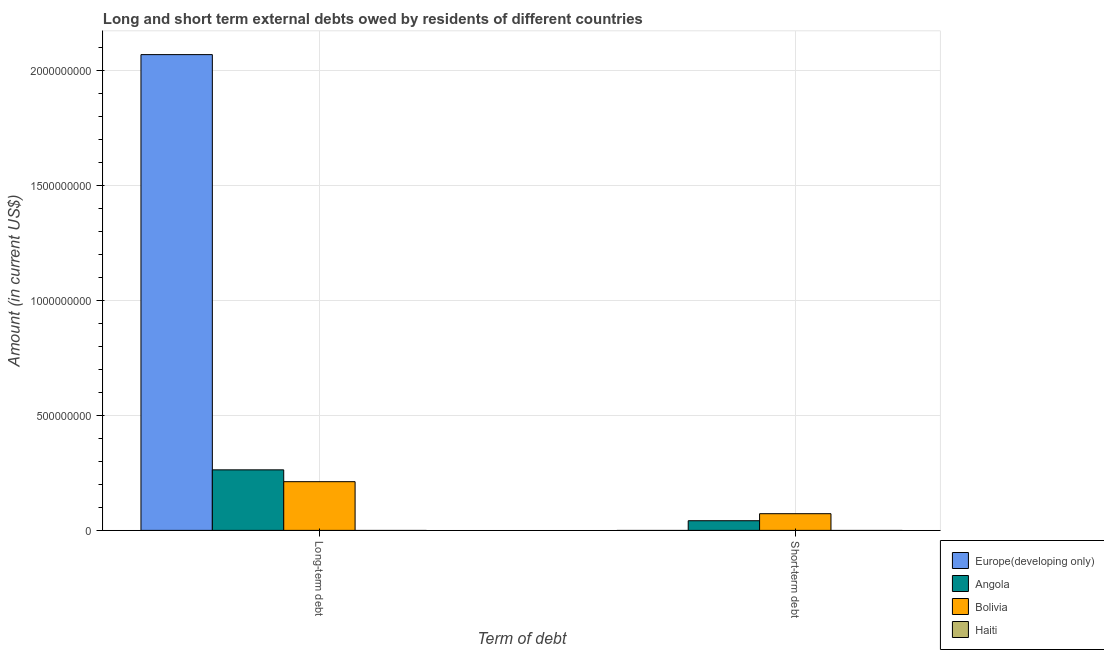How many groups of bars are there?
Offer a terse response. 2. Are the number of bars per tick equal to the number of legend labels?
Give a very brief answer. No. Are the number of bars on each tick of the X-axis equal?
Offer a terse response. No. How many bars are there on the 2nd tick from the left?
Your response must be concise. 2. What is the label of the 2nd group of bars from the left?
Ensure brevity in your answer.  Short-term debt. What is the long-term debts owed by residents in Bolivia?
Provide a short and direct response. 2.12e+08. Across all countries, what is the maximum short-term debts owed by residents?
Offer a very short reply. 7.26e+07. Across all countries, what is the minimum long-term debts owed by residents?
Provide a short and direct response. 0. What is the total short-term debts owed by residents in the graph?
Provide a succinct answer. 1.15e+08. What is the difference between the long-term debts owed by residents in Angola and that in Bolivia?
Keep it short and to the point. 5.15e+07. What is the difference between the short-term debts owed by residents in Angola and the long-term debts owed by residents in Haiti?
Your response must be concise. 4.20e+07. What is the average short-term debts owed by residents per country?
Keep it short and to the point. 2.86e+07. What is the difference between the short-term debts owed by residents and long-term debts owed by residents in Bolivia?
Provide a succinct answer. -1.39e+08. In how many countries, is the short-term debts owed by residents greater than 1500000000 US$?
Offer a very short reply. 0. What is the ratio of the long-term debts owed by residents in Angola to that in Bolivia?
Your answer should be very brief. 1.24. Is the long-term debts owed by residents in Bolivia less than that in Europe(developing only)?
Your answer should be very brief. Yes. How many bars are there?
Your answer should be very brief. 5. What is the difference between two consecutive major ticks on the Y-axis?
Offer a terse response. 5.00e+08. Does the graph contain any zero values?
Give a very brief answer. Yes. What is the title of the graph?
Keep it short and to the point. Long and short term external debts owed by residents of different countries. Does "Bhutan" appear as one of the legend labels in the graph?
Make the answer very short. No. What is the label or title of the X-axis?
Provide a short and direct response. Term of debt. What is the label or title of the Y-axis?
Provide a succinct answer. Amount (in current US$). What is the Amount (in current US$) of Europe(developing only) in Long-term debt?
Ensure brevity in your answer.  2.07e+09. What is the Amount (in current US$) of Angola in Long-term debt?
Provide a short and direct response. 2.63e+08. What is the Amount (in current US$) of Bolivia in Long-term debt?
Keep it short and to the point. 2.12e+08. What is the Amount (in current US$) of Haiti in Long-term debt?
Offer a very short reply. 0. What is the Amount (in current US$) in Angola in Short-term debt?
Provide a succinct answer. 4.20e+07. What is the Amount (in current US$) of Bolivia in Short-term debt?
Offer a terse response. 7.26e+07. Across all Term of debt, what is the maximum Amount (in current US$) in Europe(developing only)?
Provide a succinct answer. 2.07e+09. Across all Term of debt, what is the maximum Amount (in current US$) of Angola?
Your answer should be compact. 2.63e+08. Across all Term of debt, what is the maximum Amount (in current US$) of Bolivia?
Offer a very short reply. 2.12e+08. Across all Term of debt, what is the minimum Amount (in current US$) in Angola?
Your answer should be compact. 4.20e+07. Across all Term of debt, what is the minimum Amount (in current US$) in Bolivia?
Offer a terse response. 7.26e+07. What is the total Amount (in current US$) of Europe(developing only) in the graph?
Your response must be concise. 2.07e+09. What is the total Amount (in current US$) in Angola in the graph?
Ensure brevity in your answer.  3.05e+08. What is the total Amount (in current US$) in Bolivia in the graph?
Your answer should be very brief. 2.85e+08. What is the difference between the Amount (in current US$) of Angola in Long-term debt and that in Short-term debt?
Offer a very short reply. 2.21e+08. What is the difference between the Amount (in current US$) of Bolivia in Long-term debt and that in Short-term debt?
Offer a very short reply. 1.39e+08. What is the difference between the Amount (in current US$) of Europe(developing only) in Long-term debt and the Amount (in current US$) of Angola in Short-term debt?
Provide a short and direct response. 2.03e+09. What is the difference between the Amount (in current US$) in Europe(developing only) in Long-term debt and the Amount (in current US$) in Bolivia in Short-term debt?
Provide a short and direct response. 2.00e+09. What is the difference between the Amount (in current US$) in Angola in Long-term debt and the Amount (in current US$) in Bolivia in Short-term debt?
Provide a short and direct response. 1.91e+08. What is the average Amount (in current US$) of Europe(developing only) per Term of debt?
Offer a very short reply. 1.04e+09. What is the average Amount (in current US$) of Angola per Term of debt?
Ensure brevity in your answer.  1.53e+08. What is the average Amount (in current US$) of Bolivia per Term of debt?
Give a very brief answer. 1.42e+08. What is the difference between the Amount (in current US$) of Europe(developing only) and Amount (in current US$) of Angola in Long-term debt?
Keep it short and to the point. 1.81e+09. What is the difference between the Amount (in current US$) in Europe(developing only) and Amount (in current US$) in Bolivia in Long-term debt?
Provide a succinct answer. 1.86e+09. What is the difference between the Amount (in current US$) of Angola and Amount (in current US$) of Bolivia in Long-term debt?
Ensure brevity in your answer.  5.15e+07. What is the difference between the Amount (in current US$) of Angola and Amount (in current US$) of Bolivia in Short-term debt?
Make the answer very short. -3.06e+07. What is the ratio of the Amount (in current US$) in Angola in Long-term debt to that in Short-term debt?
Provide a succinct answer. 6.27. What is the ratio of the Amount (in current US$) in Bolivia in Long-term debt to that in Short-term debt?
Your response must be concise. 2.92. What is the difference between the highest and the second highest Amount (in current US$) of Angola?
Your response must be concise. 2.21e+08. What is the difference between the highest and the second highest Amount (in current US$) of Bolivia?
Provide a succinct answer. 1.39e+08. What is the difference between the highest and the lowest Amount (in current US$) in Europe(developing only)?
Provide a succinct answer. 2.07e+09. What is the difference between the highest and the lowest Amount (in current US$) of Angola?
Provide a short and direct response. 2.21e+08. What is the difference between the highest and the lowest Amount (in current US$) of Bolivia?
Keep it short and to the point. 1.39e+08. 